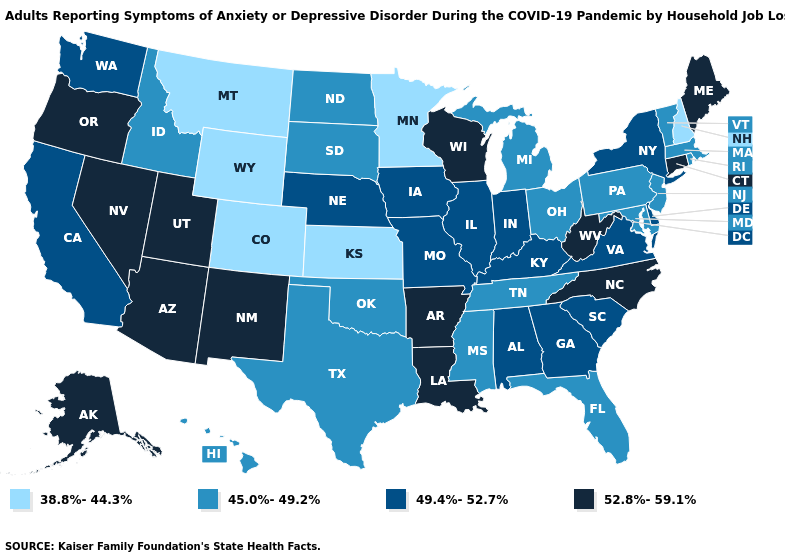What is the highest value in states that border Maryland?
Be succinct. 52.8%-59.1%. Name the states that have a value in the range 45.0%-49.2%?
Keep it brief. Florida, Hawaii, Idaho, Maryland, Massachusetts, Michigan, Mississippi, New Jersey, North Dakota, Ohio, Oklahoma, Pennsylvania, Rhode Island, South Dakota, Tennessee, Texas, Vermont. What is the lowest value in the USA?
Write a very short answer. 38.8%-44.3%. Name the states that have a value in the range 45.0%-49.2%?
Quick response, please. Florida, Hawaii, Idaho, Maryland, Massachusetts, Michigan, Mississippi, New Jersey, North Dakota, Ohio, Oklahoma, Pennsylvania, Rhode Island, South Dakota, Tennessee, Texas, Vermont. Which states have the lowest value in the USA?
Concise answer only. Colorado, Kansas, Minnesota, Montana, New Hampshire, Wyoming. Does Louisiana have the highest value in the USA?
Answer briefly. Yes. What is the value of New Hampshire?
Write a very short answer. 38.8%-44.3%. Among the states that border Illinois , which have the lowest value?
Keep it brief. Indiana, Iowa, Kentucky, Missouri. Does New Jersey have the lowest value in the USA?
Keep it brief. No. Which states hav the highest value in the South?
Write a very short answer. Arkansas, Louisiana, North Carolina, West Virginia. Name the states that have a value in the range 49.4%-52.7%?
Quick response, please. Alabama, California, Delaware, Georgia, Illinois, Indiana, Iowa, Kentucky, Missouri, Nebraska, New York, South Carolina, Virginia, Washington. What is the value of Maine?
Give a very brief answer. 52.8%-59.1%. What is the value of Idaho?
Give a very brief answer. 45.0%-49.2%. Does Oklahoma have the highest value in the South?
Give a very brief answer. No. Name the states that have a value in the range 52.8%-59.1%?
Write a very short answer. Alaska, Arizona, Arkansas, Connecticut, Louisiana, Maine, Nevada, New Mexico, North Carolina, Oregon, Utah, West Virginia, Wisconsin. 